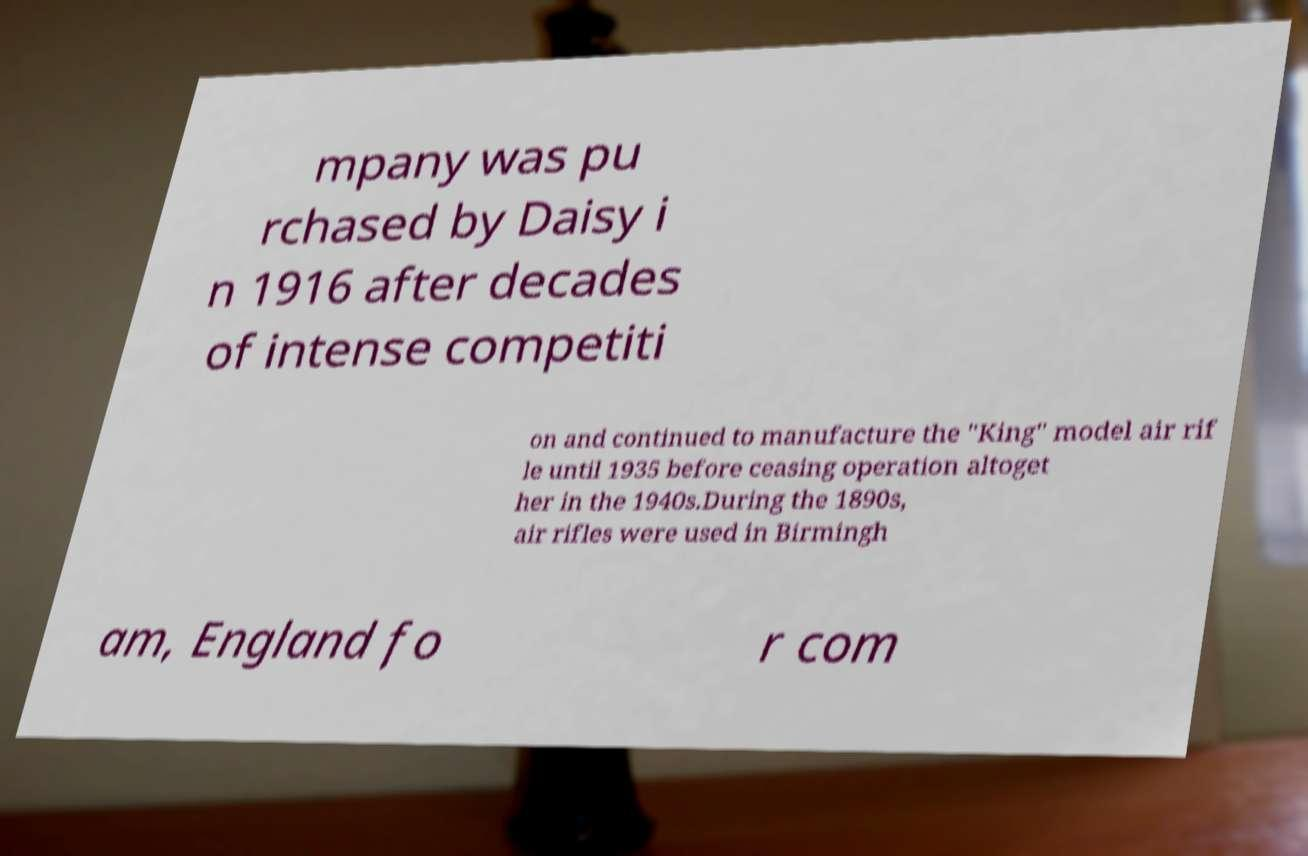For documentation purposes, I need the text within this image transcribed. Could you provide that? mpany was pu rchased by Daisy i n 1916 after decades of intense competiti on and continued to manufacture the "King" model air rif le until 1935 before ceasing operation altoget her in the 1940s.During the 1890s, air rifles were used in Birmingh am, England fo r com 